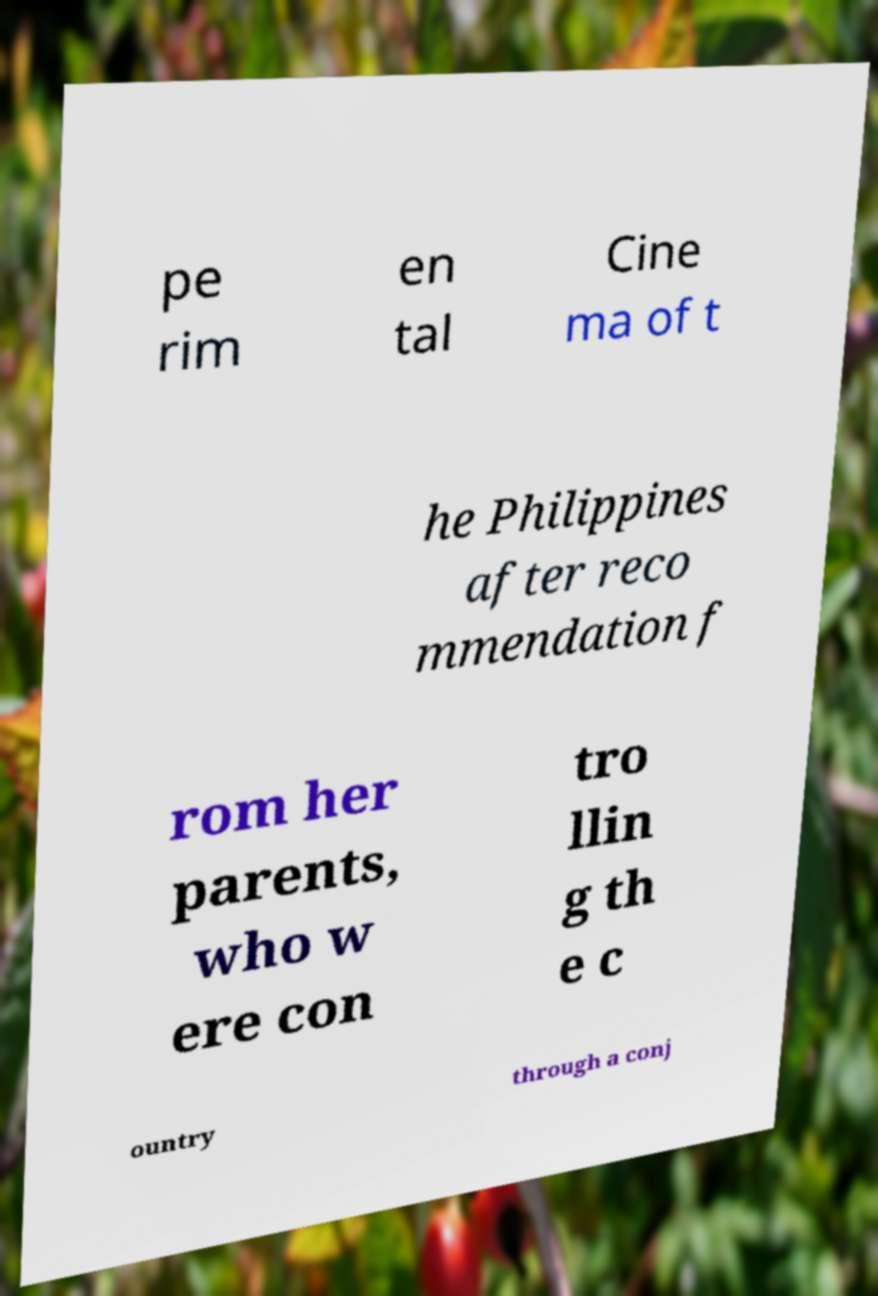Can you read and provide the text displayed in the image?This photo seems to have some interesting text. Can you extract and type it out for me? pe rim en tal Cine ma of t he Philippines after reco mmendation f rom her parents, who w ere con tro llin g th e c ountry through a conj 